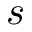Convert formula to latex. <formula><loc_0><loc_0><loc_500><loc_500>s</formula> 